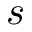Convert formula to latex. <formula><loc_0><loc_0><loc_500><loc_500>s</formula> 